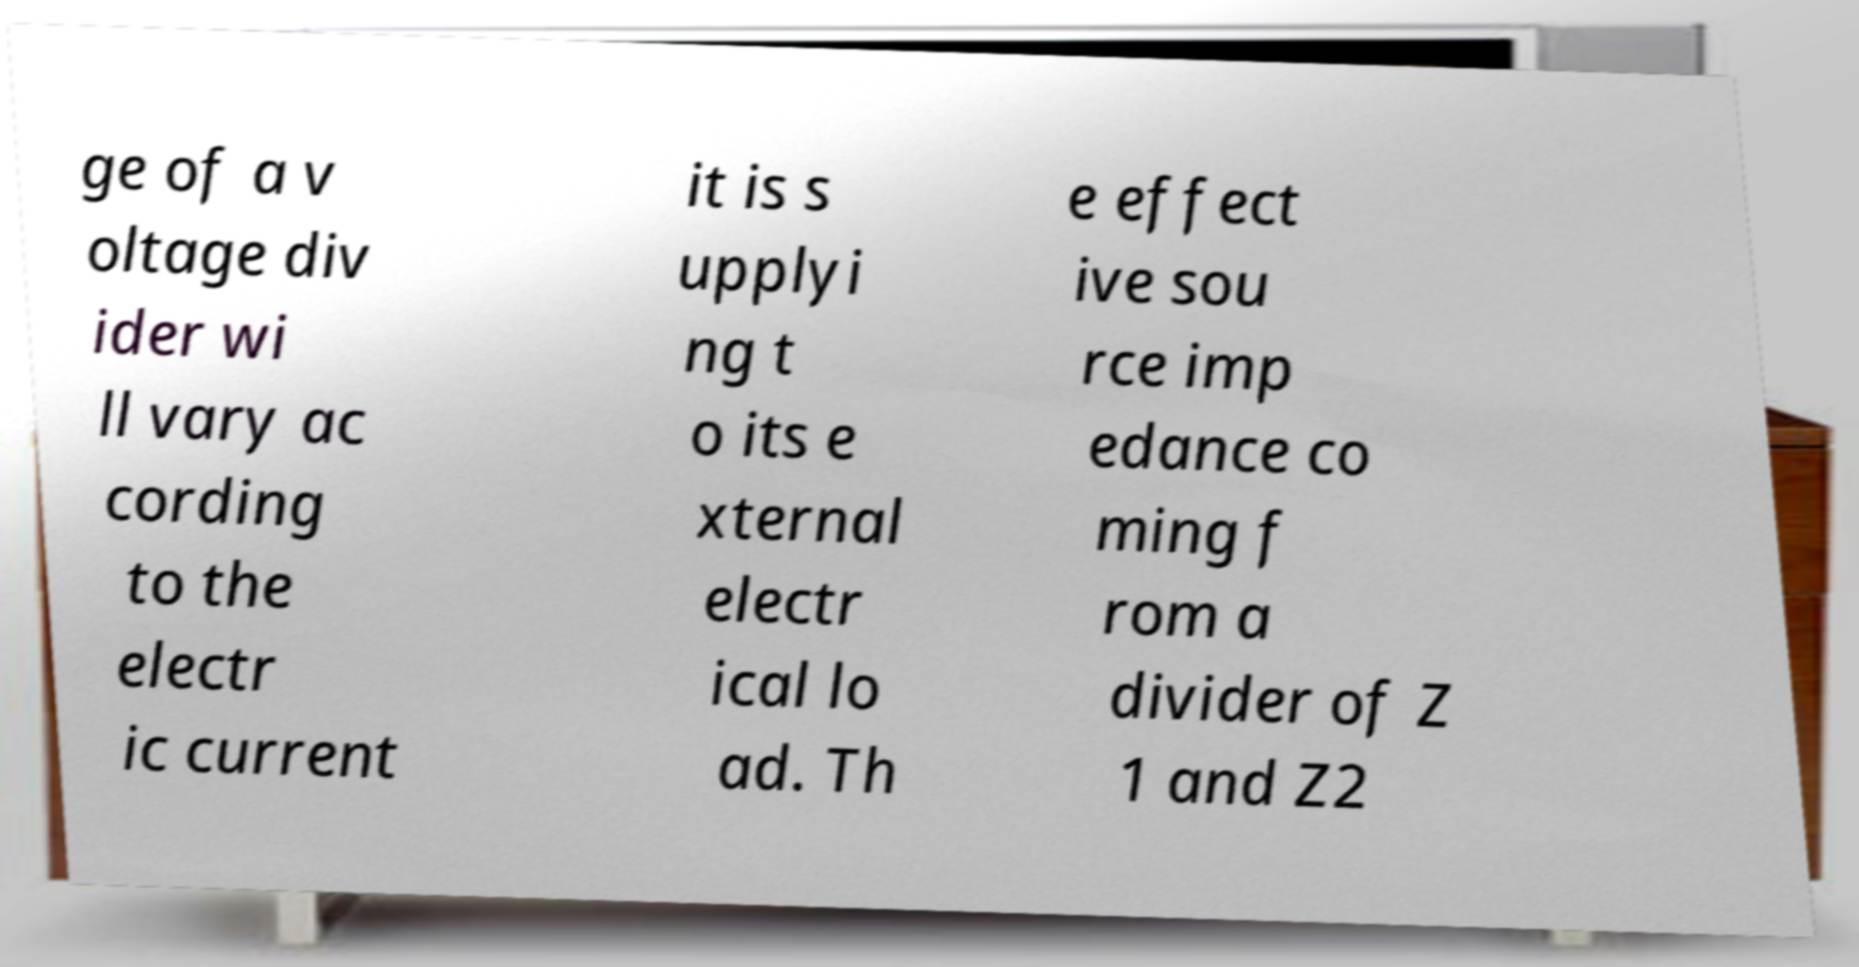What messages or text are displayed in this image? I need them in a readable, typed format. ge of a v oltage div ider wi ll vary ac cording to the electr ic current it is s upplyi ng t o its e xternal electr ical lo ad. Th e effect ive sou rce imp edance co ming f rom a divider of Z 1 and Z2 